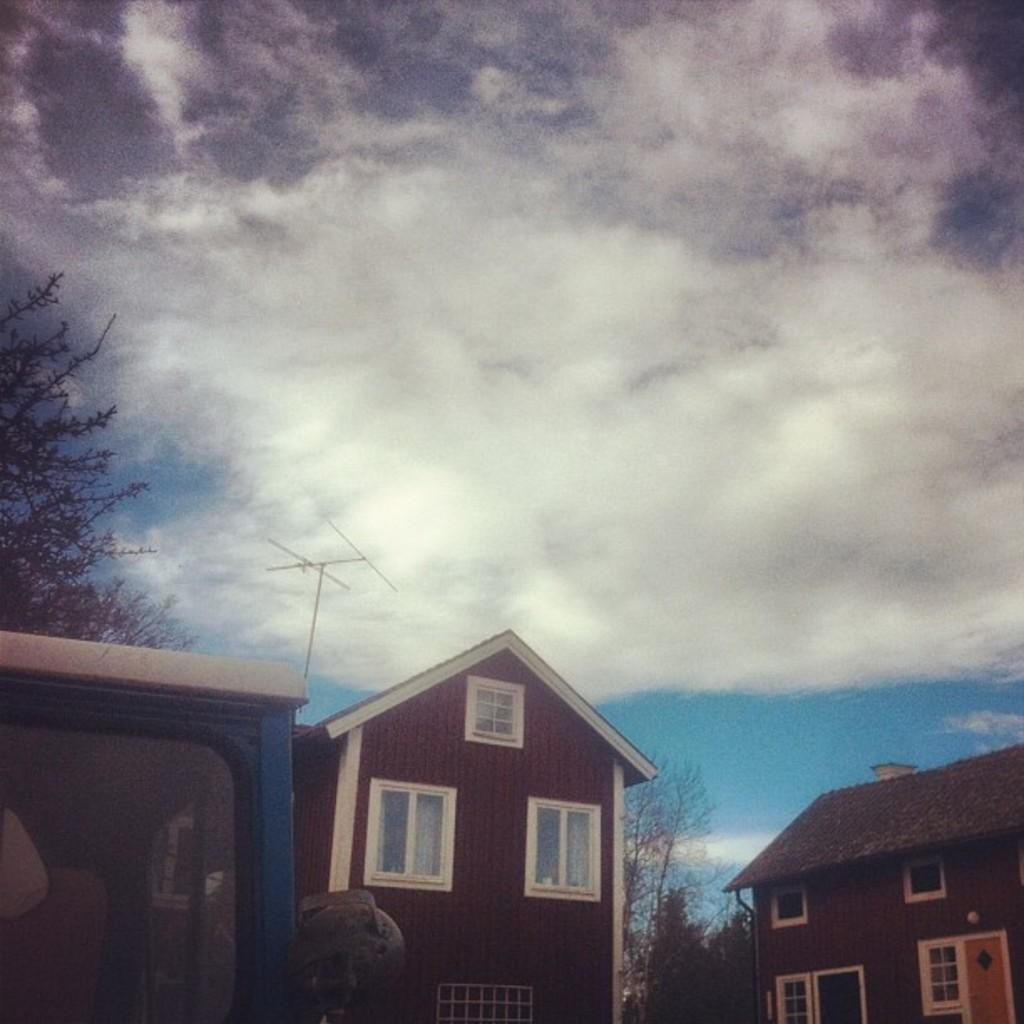What structures are located at the bottom of the image? There are sheds at the bottom of the image. What type of vegetation can be seen in the background of the image? There are trees in the background of the image. What is visible in the background of the image? The sky is visible in the background of the image. What type of butter is being used to paint the sheds in the image? There is no butter present in the image, and the sheds are not being painted. Can you tell me how many dogs are visible in the image? There are no dogs present in the image. 